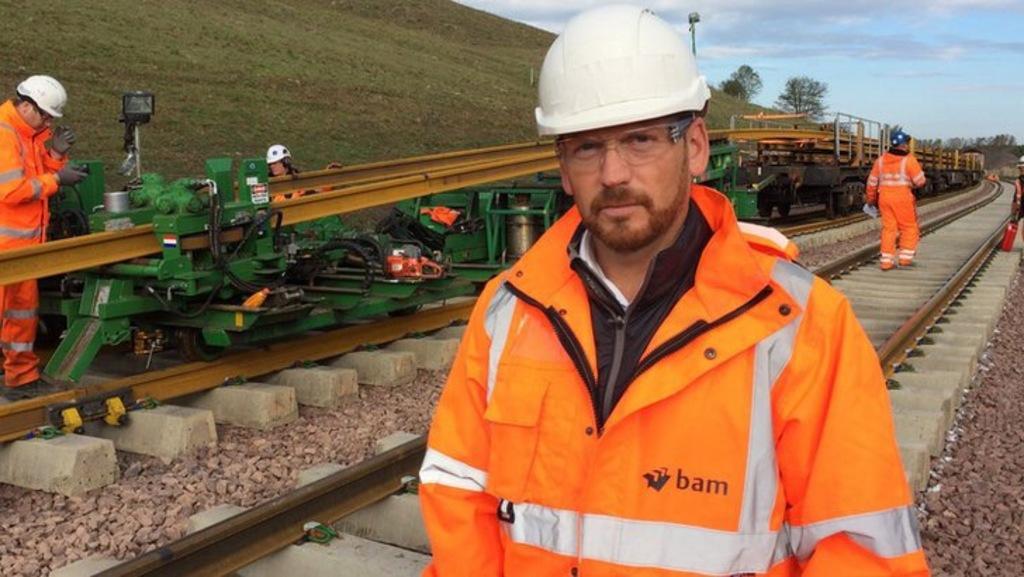Can you describe this image briefly? In this image we can see some people standing on the track. On the left side we can see a truck, motor with pipes on the track. We can see that two people are checking it. On the backside we can see a hill, trees, pole and the sky which looks cloudy. 